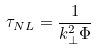<formula> <loc_0><loc_0><loc_500><loc_500>\tau _ { N L } = \frac { 1 } { k _ { \perp } ^ { 2 } \Phi }</formula> 